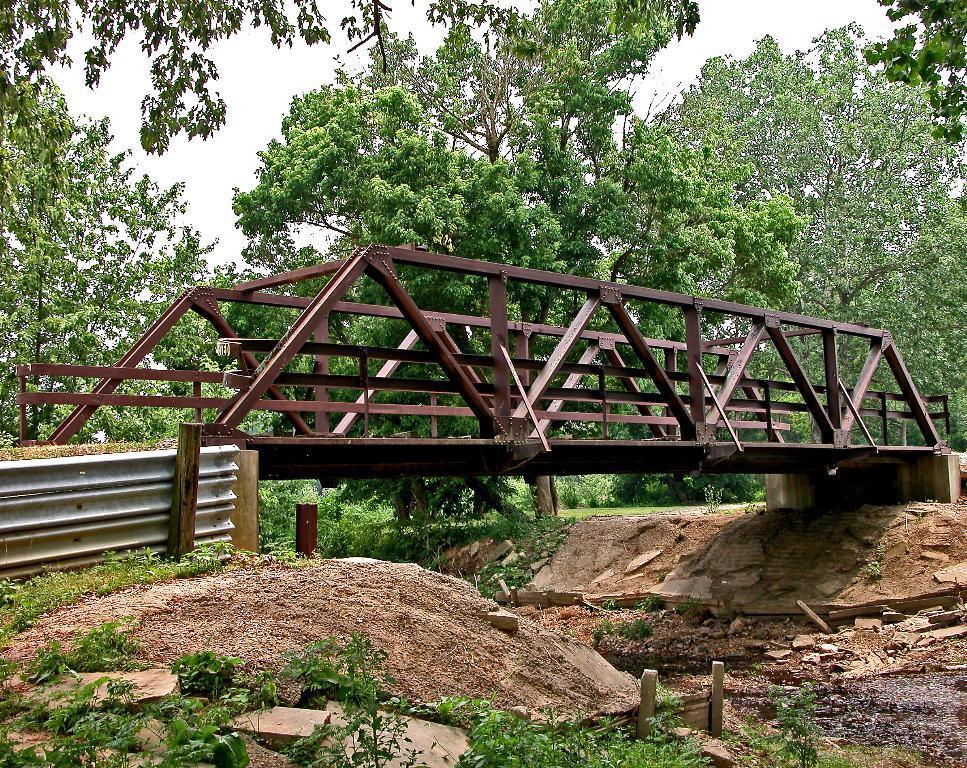How would you summarize this image in a sentence or two? In the center of the image, we can see a bridge and there are railings. In the background, there are trees and we can see an asbestos sheet. At the bottom, there are rocks and there is ground. 